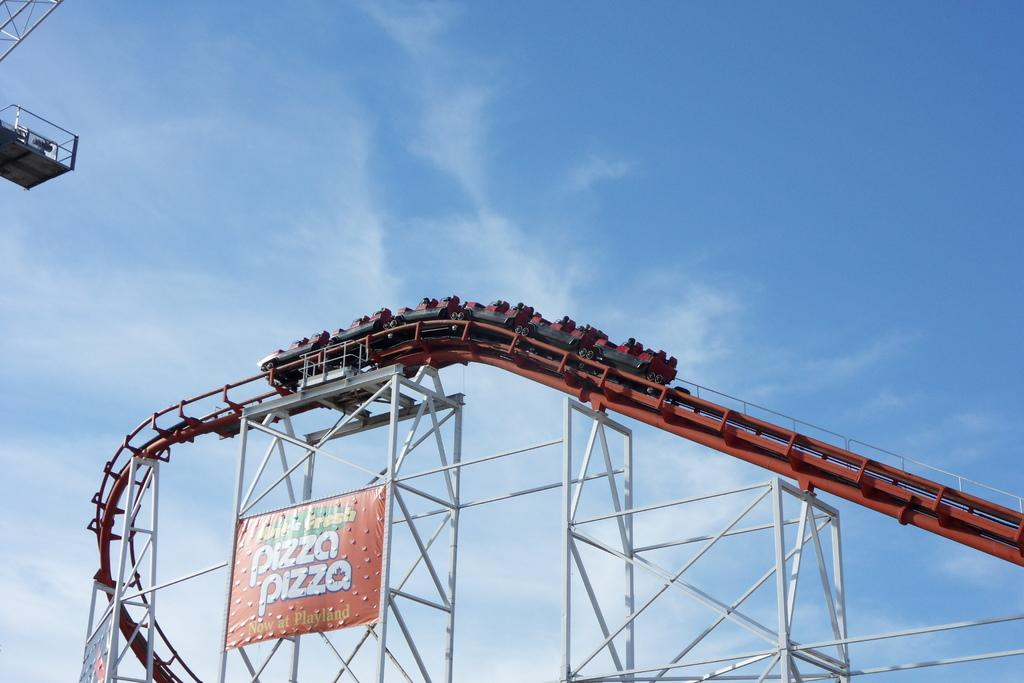<image>
Summarize the visual content of the image. A sign on a roller coaster advertises pizza. 